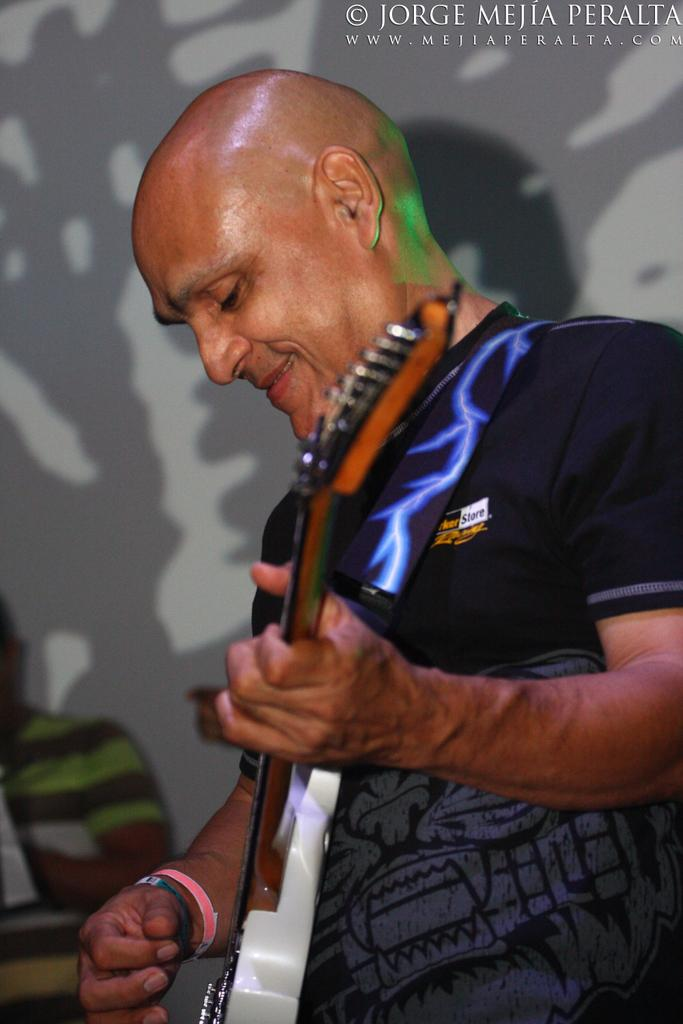What is the man in the image doing? The man is playing the guitar in the image. What is the man wearing in the image? The man is wearing a black t-shirt in the image. Can you describe any other details about the man in the image? Unfortunately, the provided facts do not mention any other details about the man. How many snails can be seen crawling on the basin in the image? There are no snails or basins present in the image; it features a man playing the guitar while wearing a black t-shirt. 